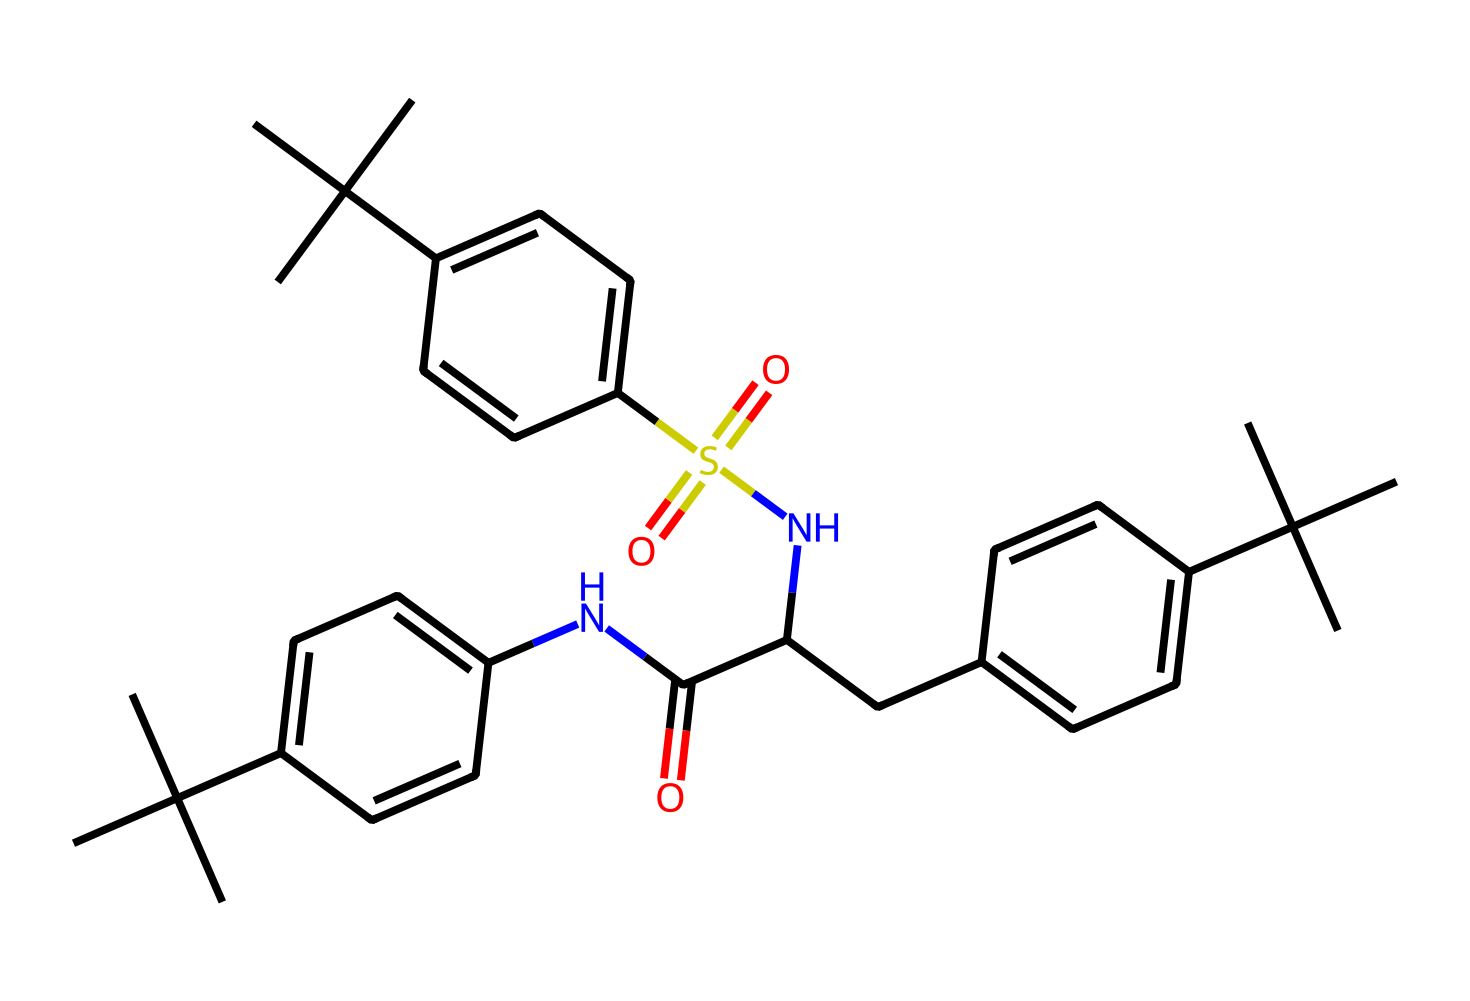What is the primary functional group in this chemical? The structure shows sulfonamide features, indicated by the presence of the sulfonic group (O=S(=O)(N)). This is key in determining its functional behavior.
Answer: sulfonamide How many aromatic rings are present in this structure? By analyzing the chemical structure, there are three distinct benzene rings visible via the C=C components, indicating each one is aromatic.
Answer: three What type of bond connects the nitrogen to the carbon in its amide groups? The bonds connecting the nitrogen (N) to the carbon (C) in the amide groups are characterized as covalent bonds due to the sharing of electrons between these atoms.
Answer: covalent How many methyl groups are attached to the structure? Upon reviewing the chemical, there are twelve carbon atoms indicated with branches as methyl groups connected to the major carbon chains, confirming their presence around the rings.
Answer: twelve Which element is primarily responsible for the sweetness of this compound? The nitrogen components of this structure suggest its role in imparting a sweet taste, typical for many artificial sweeteners that often include nitrogen in amine or amide form.
Answer: nitrogen What elements are present in this chemical? Upon examining the structure, both sulfur (S), oxygen (O), nitrogen (N), and carbon (C) are identified, highlighting the compound's diverse elemental makeup.
Answer: sulfur, oxygen, nitrogen, carbon 